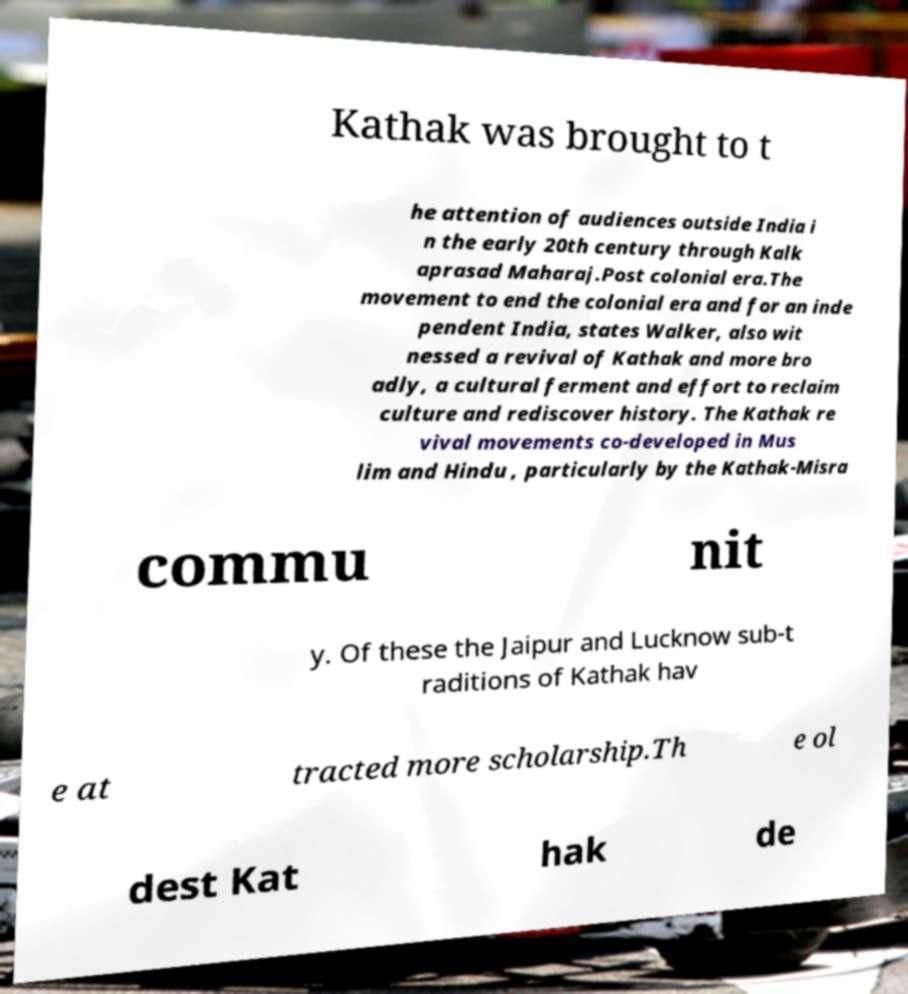Can you accurately transcribe the text from the provided image for me? Kathak was brought to t he attention of audiences outside India i n the early 20th century through Kalk aprasad Maharaj.Post colonial era.The movement to end the colonial era and for an inde pendent India, states Walker, also wit nessed a revival of Kathak and more bro adly, a cultural ferment and effort to reclaim culture and rediscover history. The Kathak re vival movements co-developed in Mus lim and Hindu , particularly by the Kathak-Misra commu nit y. Of these the Jaipur and Lucknow sub-t raditions of Kathak hav e at tracted more scholarship.Th e ol dest Kat hak de 